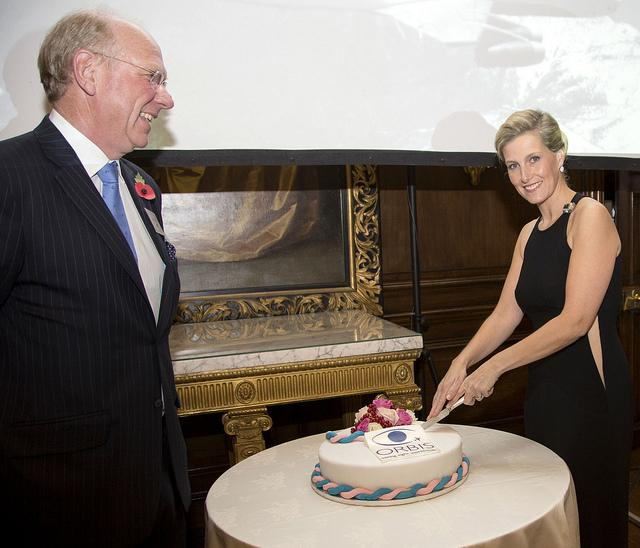What is the name of the red flower on the man's lapel?

Choices:
A) rose
B) poppy
C) daisy
D) chrysanthemum poppy 